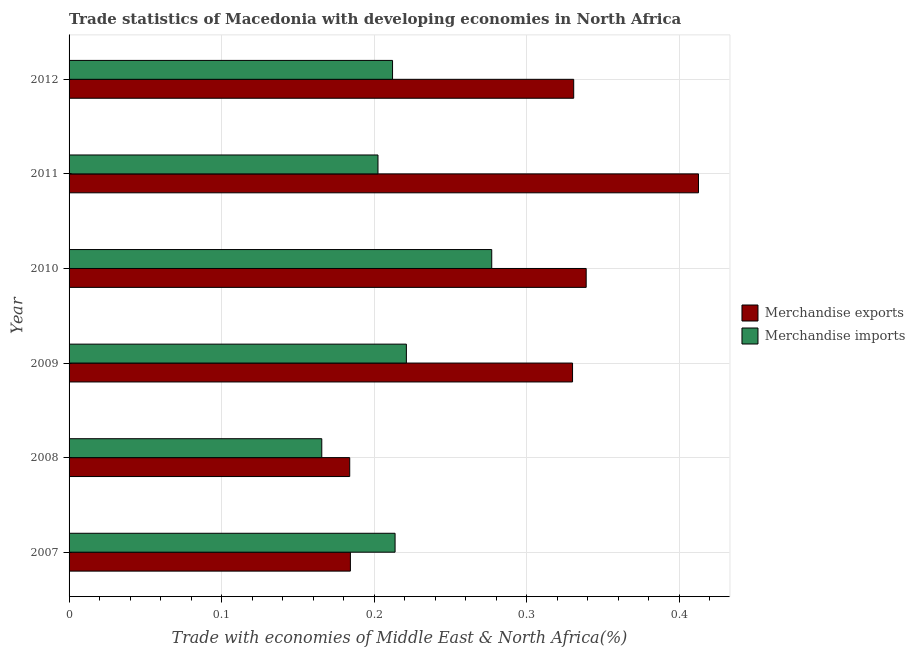How many bars are there on the 2nd tick from the bottom?
Make the answer very short. 2. What is the merchandise exports in 2011?
Provide a succinct answer. 0.41. Across all years, what is the maximum merchandise exports?
Provide a short and direct response. 0.41. Across all years, what is the minimum merchandise exports?
Your answer should be very brief. 0.18. In which year was the merchandise exports maximum?
Keep it short and to the point. 2011. In which year was the merchandise imports minimum?
Your answer should be very brief. 2008. What is the total merchandise exports in the graph?
Make the answer very short. 1.78. What is the difference between the merchandise imports in 2008 and that in 2009?
Make the answer very short. -0.06. What is the difference between the merchandise exports in 2008 and the merchandise imports in 2012?
Your answer should be compact. -0.03. What is the average merchandise imports per year?
Ensure brevity in your answer.  0.21. In the year 2009, what is the difference between the merchandise exports and merchandise imports?
Make the answer very short. 0.11. In how many years, is the merchandise exports greater than 0.12000000000000001 %?
Your answer should be compact. 6. What is the ratio of the merchandise imports in 2008 to that in 2011?
Give a very brief answer. 0.82. Is the merchandise imports in 2007 less than that in 2010?
Ensure brevity in your answer.  Yes. Is the difference between the merchandise exports in 2009 and 2010 greater than the difference between the merchandise imports in 2009 and 2010?
Keep it short and to the point. Yes. What is the difference between the highest and the second highest merchandise imports?
Your answer should be compact. 0.06. What is the difference between the highest and the lowest merchandise exports?
Keep it short and to the point. 0.23. In how many years, is the merchandise exports greater than the average merchandise exports taken over all years?
Make the answer very short. 4. How many bars are there?
Your response must be concise. 12. Are all the bars in the graph horizontal?
Keep it short and to the point. Yes. What is the difference between two consecutive major ticks on the X-axis?
Offer a very short reply. 0.1. Are the values on the major ticks of X-axis written in scientific E-notation?
Ensure brevity in your answer.  No. Does the graph contain any zero values?
Offer a very short reply. No. Does the graph contain grids?
Your answer should be compact. Yes. Where does the legend appear in the graph?
Your response must be concise. Center right. How are the legend labels stacked?
Keep it short and to the point. Vertical. What is the title of the graph?
Provide a succinct answer. Trade statistics of Macedonia with developing economies in North Africa. Does "National Visitors" appear as one of the legend labels in the graph?
Give a very brief answer. No. What is the label or title of the X-axis?
Keep it short and to the point. Trade with economies of Middle East & North Africa(%). What is the label or title of the Y-axis?
Your answer should be compact. Year. What is the Trade with economies of Middle East & North Africa(%) in Merchandise exports in 2007?
Ensure brevity in your answer.  0.18. What is the Trade with economies of Middle East & North Africa(%) in Merchandise imports in 2007?
Give a very brief answer. 0.21. What is the Trade with economies of Middle East & North Africa(%) of Merchandise exports in 2008?
Your response must be concise. 0.18. What is the Trade with economies of Middle East & North Africa(%) in Merchandise imports in 2008?
Your response must be concise. 0.17. What is the Trade with economies of Middle East & North Africa(%) of Merchandise exports in 2009?
Keep it short and to the point. 0.33. What is the Trade with economies of Middle East & North Africa(%) of Merchandise imports in 2009?
Your response must be concise. 0.22. What is the Trade with economies of Middle East & North Africa(%) in Merchandise exports in 2010?
Offer a very short reply. 0.34. What is the Trade with economies of Middle East & North Africa(%) in Merchandise imports in 2010?
Your answer should be compact. 0.28. What is the Trade with economies of Middle East & North Africa(%) in Merchandise exports in 2011?
Offer a very short reply. 0.41. What is the Trade with economies of Middle East & North Africa(%) in Merchandise imports in 2011?
Make the answer very short. 0.2. What is the Trade with economies of Middle East & North Africa(%) in Merchandise exports in 2012?
Offer a terse response. 0.33. What is the Trade with economies of Middle East & North Africa(%) of Merchandise imports in 2012?
Provide a short and direct response. 0.21. Across all years, what is the maximum Trade with economies of Middle East & North Africa(%) in Merchandise exports?
Provide a succinct answer. 0.41. Across all years, what is the maximum Trade with economies of Middle East & North Africa(%) of Merchandise imports?
Your response must be concise. 0.28. Across all years, what is the minimum Trade with economies of Middle East & North Africa(%) in Merchandise exports?
Your answer should be compact. 0.18. Across all years, what is the minimum Trade with economies of Middle East & North Africa(%) of Merchandise imports?
Ensure brevity in your answer.  0.17. What is the total Trade with economies of Middle East & North Africa(%) in Merchandise exports in the graph?
Give a very brief answer. 1.78. What is the total Trade with economies of Middle East & North Africa(%) in Merchandise imports in the graph?
Offer a very short reply. 1.29. What is the difference between the Trade with economies of Middle East & North Africa(%) of Merchandise exports in 2007 and that in 2008?
Your answer should be compact. 0. What is the difference between the Trade with economies of Middle East & North Africa(%) of Merchandise imports in 2007 and that in 2008?
Your response must be concise. 0.05. What is the difference between the Trade with economies of Middle East & North Africa(%) in Merchandise exports in 2007 and that in 2009?
Provide a succinct answer. -0.15. What is the difference between the Trade with economies of Middle East & North Africa(%) in Merchandise imports in 2007 and that in 2009?
Your answer should be compact. -0.01. What is the difference between the Trade with economies of Middle East & North Africa(%) of Merchandise exports in 2007 and that in 2010?
Provide a short and direct response. -0.15. What is the difference between the Trade with economies of Middle East & North Africa(%) of Merchandise imports in 2007 and that in 2010?
Ensure brevity in your answer.  -0.06. What is the difference between the Trade with economies of Middle East & North Africa(%) in Merchandise exports in 2007 and that in 2011?
Ensure brevity in your answer.  -0.23. What is the difference between the Trade with economies of Middle East & North Africa(%) in Merchandise imports in 2007 and that in 2011?
Provide a succinct answer. 0.01. What is the difference between the Trade with economies of Middle East & North Africa(%) in Merchandise exports in 2007 and that in 2012?
Your answer should be compact. -0.15. What is the difference between the Trade with economies of Middle East & North Africa(%) in Merchandise imports in 2007 and that in 2012?
Provide a succinct answer. 0. What is the difference between the Trade with economies of Middle East & North Africa(%) of Merchandise exports in 2008 and that in 2009?
Ensure brevity in your answer.  -0.15. What is the difference between the Trade with economies of Middle East & North Africa(%) in Merchandise imports in 2008 and that in 2009?
Ensure brevity in your answer.  -0.06. What is the difference between the Trade with economies of Middle East & North Africa(%) in Merchandise exports in 2008 and that in 2010?
Offer a very short reply. -0.15. What is the difference between the Trade with economies of Middle East & North Africa(%) in Merchandise imports in 2008 and that in 2010?
Give a very brief answer. -0.11. What is the difference between the Trade with economies of Middle East & North Africa(%) in Merchandise exports in 2008 and that in 2011?
Provide a short and direct response. -0.23. What is the difference between the Trade with economies of Middle East & North Africa(%) of Merchandise imports in 2008 and that in 2011?
Provide a short and direct response. -0.04. What is the difference between the Trade with economies of Middle East & North Africa(%) in Merchandise exports in 2008 and that in 2012?
Your answer should be very brief. -0.15. What is the difference between the Trade with economies of Middle East & North Africa(%) in Merchandise imports in 2008 and that in 2012?
Make the answer very short. -0.05. What is the difference between the Trade with economies of Middle East & North Africa(%) of Merchandise exports in 2009 and that in 2010?
Your response must be concise. -0.01. What is the difference between the Trade with economies of Middle East & North Africa(%) in Merchandise imports in 2009 and that in 2010?
Your response must be concise. -0.06. What is the difference between the Trade with economies of Middle East & North Africa(%) of Merchandise exports in 2009 and that in 2011?
Your answer should be very brief. -0.08. What is the difference between the Trade with economies of Middle East & North Africa(%) in Merchandise imports in 2009 and that in 2011?
Make the answer very short. 0.02. What is the difference between the Trade with economies of Middle East & North Africa(%) of Merchandise exports in 2009 and that in 2012?
Give a very brief answer. -0. What is the difference between the Trade with economies of Middle East & North Africa(%) in Merchandise imports in 2009 and that in 2012?
Your answer should be compact. 0.01. What is the difference between the Trade with economies of Middle East & North Africa(%) in Merchandise exports in 2010 and that in 2011?
Your answer should be compact. -0.07. What is the difference between the Trade with economies of Middle East & North Africa(%) in Merchandise imports in 2010 and that in 2011?
Make the answer very short. 0.07. What is the difference between the Trade with economies of Middle East & North Africa(%) of Merchandise exports in 2010 and that in 2012?
Keep it short and to the point. 0.01. What is the difference between the Trade with economies of Middle East & North Africa(%) of Merchandise imports in 2010 and that in 2012?
Your answer should be compact. 0.07. What is the difference between the Trade with economies of Middle East & North Africa(%) in Merchandise exports in 2011 and that in 2012?
Make the answer very short. 0.08. What is the difference between the Trade with economies of Middle East & North Africa(%) of Merchandise imports in 2011 and that in 2012?
Make the answer very short. -0.01. What is the difference between the Trade with economies of Middle East & North Africa(%) of Merchandise exports in 2007 and the Trade with economies of Middle East & North Africa(%) of Merchandise imports in 2008?
Provide a succinct answer. 0.02. What is the difference between the Trade with economies of Middle East & North Africa(%) of Merchandise exports in 2007 and the Trade with economies of Middle East & North Africa(%) of Merchandise imports in 2009?
Ensure brevity in your answer.  -0.04. What is the difference between the Trade with economies of Middle East & North Africa(%) in Merchandise exports in 2007 and the Trade with economies of Middle East & North Africa(%) in Merchandise imports in 2010?
Offer a very short reply. -0.09. What is the difference between the Trade with economies of Middle East & North Africa(%) in Merchandise exports in 2007 and the Trade with economies of Middle East & North Africa(%) in Merchandise imports in 2011?
Offer a very short reply. -0.02. What is the difference between the Trade with economies of Middle East & North Africa(%) in Merchandise exports in 2007 and the Trade with economies of Middle East & North Africa(%) in Merchandise imports in 2012?
Provide a succinct answer. -0.03. What is the difference between the Trade with economies of Middle East & North Africa(%) in Merchandise exports in 2008 and the Trade with economies of Middle East & North Africa(%) in Merchandise imports in 2009?
Provide a succinct answer. -0.04. What is the difference between the Trade with economies of Middle East & North Africa(%) in Merchandise exports in 2008 and the Trade with economies of Middle East & North Africa(%) in Merchandise imports in 2010?
Your answer should be very brief. -0.09. What is the difference between the Trade with economies of Middle East & North Africa(%) of Merchandise exports in 2008 and the Trade with economies of Middle East & North Africa(%) of Merchandise imports in 2011?
Give a very brief answer. -0.02. What is the difference between the Trade with economies of Middle East & North Africa(%) in Merchandise exports in 2008 and the Trade with economies of Middle East & North Africa(%) in Merchandise imports in 2012?
Your answer should be compact. -0.03. What is the difference between the Trade with economies of Middle East & North Africa(%) in Merchandise exports in 2009 and the Trade with economies of Middle East & North Africa(%) in Merchandise imports in 2010?
Your answer should be compact. 0.05. What is the difference between the Trade with economies of Middle East & North Africa(%) of Merchandise exports in 2009 and the Trade with economies of Middle East & North Africa(%) of Merchandise imports in 2011?
Provide a succinct answer. 0.13. What is the difference between the Trade with economies of Middle East & North Africa(%) of Merchandise exports in 2009 and the Trade with economies of Middle East & North Africa(%) of Merchandise imports in 2012?
Make the answer very short. 0.12. What is the difference between the Trade with economies of Middle East & North Africa(%) in Merchandise exports in 2010 and the Trade with economies of Middle East & North Africa(%) in Merchandise imports in 2011?
Keep it short and to the point. 0.14. What is the difference between the Trade with economies of Middle East & North Africa(%) of Merchandise exports in 2010 and the Trade with economies of Middle East & North Africa(%) of Merchandise imports in 2012?
Make the answer very short. 0.13. What is the difference between the Trade with economies of Middle East & North Africa(%) of Merchandise exports in 2011 and the Trade with economies of Middle East & North Africa(%) of Merchandise imports in 2012?
Provide a succinct answer. 0.2. What is the average Trade with economies of Middle East & North Africa(%) of Merchandise exports per year?
Offer a very short reply. 0.3. What is the average Trade with economies of Middle East & North Africa(%) of Merchandise imports per year?
Offer a very short reply. 0.22. In the year 2007, what is the difference between the Trade with economies of Middle East & North Africa(%) in Merchandise exports and Trade with economies of Middle East & North Africa(%) in Merchandise imports?
Provide a short and direct response. -0.03. In the year 2008, what is the difference between the Trade with economies of Middle East & North Africa(%) of Merchandise exports and Trade with economies of Middle East & North Africa(%) of Merchandise imports?
Keep it short and to the point. 0.02. In the year 2009, what is the difference between the Trade with economies of Middle East & North Africa(%) of Merchandise exports and Trade with economies of Middle East & North Africa(%) of Merchandise imports?
Provide a short and direct response. 0.11. In the year 2010, what is the difference between the Trade with economies of Middle East & North Africa(%) in Merchandise exports and Trade with economies of Middle East & North Africa(%) in Merchandise imports?
Keep it short and to the point. 0.06. In the year 2011, what is the difference between the Trade with economies of Middle East & North Africa(%) of Merchandise exports and Trade with economies of Middle East & North Africa(%) of Merchandise imports?
Your response must be concise. 0.21. In the year 2012, what is the difference between the Trade with economies of Middle East & North Africa(%) of Merchandise exports and Trade with economies of Middle East & North Africa(%) of Merchandise imports?
Ensure brevity in your answer.  0.12. What is the ratio of the Trade with economies of Middle East & North Africa(%) of Merchandise imports in 2007 to that in 2008?
Offer a very short reply. 1.29. What is the ratio of the Trade with economies of Middle East & North Africa(%) in Merchandise exports in 2007 to that in 2009?
Your answer should be very brief. 0.56. What is the ratio of the Trade with economies of Middle East & North Africa(%) in Merchandise imports in 2007 to that in 2009?
Your answer should be compact. 0.97. What is the ratio of the Trade with economies of Middle East & North Africa(%) in Merchandise exports in 2007 to that in 2010?
Provide a short and direct response. 0.54. What is the ratio of the Trade with economies of Middle East & North Africa(%) in Merchandise imports in 2007 to that in 2010?
Offer a very short reply. 0.77. What is the ratio of the Trade with economies of Middle East & North Africa(%) of Merchandise exports in 2007 to that in 2011?
Provide a succinct answer. 0.45. What is the ratio of the Trade with economies of Middle East & North Africa(%) in Merchandise imports in 2007 to that in 2011?
Ensure brevity in your answer.  1.06. What is the ratio of the Trade with economies of Middle East & North Africa(%) in Merchandise exports in 2007 to that in 2012?
Ensure brevity in your answer.  0.56. What is the ratio of the Trade with economies of Middle East & North Africa(%) of Merchandise exports in 2008 to that in 2009?
Offer a terse response. 0.56. What is the ratio of the Trade with economies of Middle East & North Africa(%) of Merchandise imports in 2008 to that in 2009?
Offer a terse response. 0.75. What is the ratio of the Trade with economies of Middle East & North Africa(%) in Merchandise exports in 2008 to that in 2010?
Make the answer very short. 0.54. What is the ratio of the Trade with economies of Middle East & North Africa(%) of Merchandise imports in 2008 to that in 2010?
Offer a very short reply. 0.6. What is the ratio of the Trade with economies of Middle East & North Africa(%) of Merchandise exports in 2008 to that in 2011?
Keep it short and to the point. 0.45. What is the ratio of the Trade with economies of Middle East & North Africa(%) in Merchandise imports in 2008 to that in 2011?
Give a very brief answer. 0.82. What is the ratio of the Trade with economies of Middle East & North Africa(%) in Merchandise exports in 2008 to that in 2012?
Provide a succinct answer. 0.56. What is the ratio of the Trade with economies of Middle East & North Africa(%) of Merchandise imports in 2008 to that in 2012?
Make the answer very short. 0.78. What is the ratio of the Trade with economies of Middle East & North Africa(%) of Merchandise exports in 2009 to that in 2010?
Offer a terse response. 0.97. What is the ratio of the Trade with economies of Middle East & North Africa(%) in Merchandise imports in 2009 to that in 2010?
Provide a short and direct response. 0.8. What is the ratio of the Trade with economies of Middle East & North Africa(%) in Merchandise exports in 2009 to that in 2011?
Give a very brief answer. 0.8. What is the ratio of the Trade with economies of Middle East & North Africa(%) in Merchandise imports in 2009 to that in 2011?
Keep it short and to the point. 1.09. What is the ratio of the Trade with economies of Middle East & North Africa(%) in Merchandise imports in 2009 to that in 2012?
Offer a terse response. 1.04. What is the ratio of the Trade with economies of Middle East & North Africa(%) in Merchandise exports in 2010 to that in 2011?
Give a very brief answer. 0.82. What is the ratio of the Trade with economies of Middle East & North Africa(%) of Merchandise imports in 2010 to that in 2011?
Provide a succinct answer. 1.37. What is the ratio of the Trade with economies of Middle East & North Africa(%) in Merchandise exports in 2010 to that in 2012?
Your response must be concise. 1.02. What is the ratio of the Trade with economies of Middle East & North Africa(%) in Merchandise imports in 2010 to that in 2012?
Your answer should be compact. 1.31. What is the ratio of the Trade with economies of Middle East & North Africa(%) of Merchandise exports in 2011 to that in 2012?
Provide a succinct answer. 1.25. What is the ratio of the Trade with economies of Middle East & North Africa(%) of Merchandise imports in 2011 to that in 2012?
Provide a short and direct response. 0.95. What is the difference between the highest and the second highest Trade with economies of Middle East & North Africa(%) in Merchandise exports?
Your answer should be compact. 0.07. What is the difference between the highest and the second highest Trade with economies of Middle East & North Africa(%) in Merchandise imports?
Provide a succinct answer. 0.06. What is the difference between the highest and the lowest Trade with economies of Middle East & North Africa(%) of Merchandise exports?
Ensure brevity in your answer.  0.23. What is the difference between the highest and the lowest Trade with economies of Middle East & North Africa(%) in Merchandise imports?
Provide a succinct answer. 0.11. 